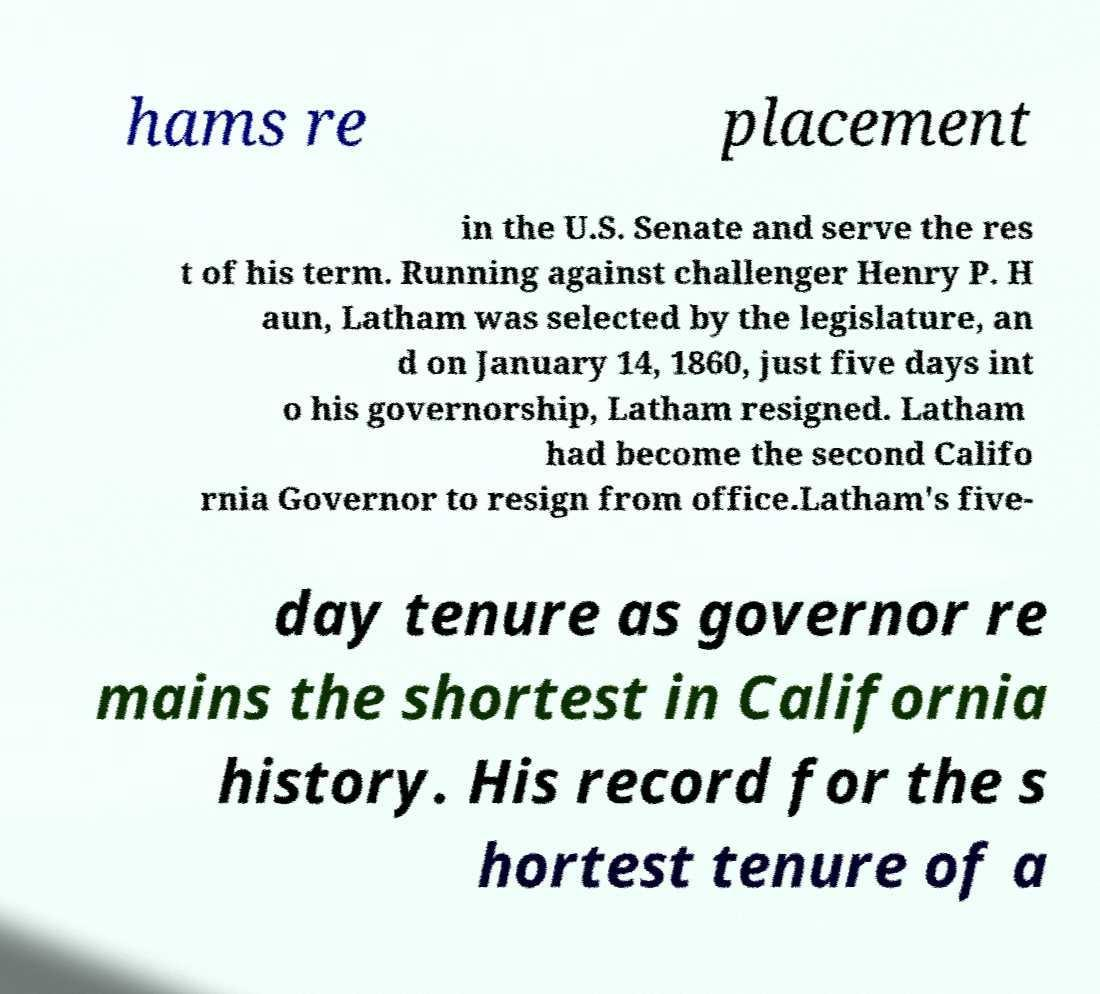Please read and relay the text visible in this image. What does it say? hams re placement in the U.S. Senate and serve the res t of his term. Running against challenger Henry P. H aun, Latham was selected by the legislature, an d on January 14, 1860, just five days int o his governorship, Latham resigned. Latham had become the second Califo rnia Governor to resign from office.Latham's five- day tenure as governor re mains the shortest in California history. His record for the s hortest tenure of a 